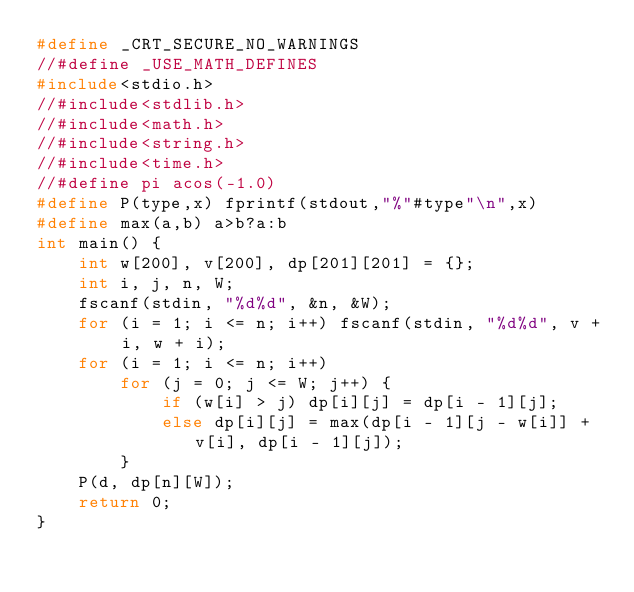<code> <loc_0><loc_0><loc_500><loc_500><_C_>#define _CRT_SECURE_NO_WARNINGS
//#define _USE_MATH_DEFINES
#include<stdio.h>
//#include<stdlib.h>
//#include<math.h>
//#include<string.h>
//#include<time.h>
//#define pi acos(-1.0)
#define P(type,x) fprintf(stdout,"%"#type"\n",x)
#define max(a,b) a>b?a:b
int main() {
	int w[200], v[200], dp[201][201] = {};
	int i, j, n, W;
	fscanf(stdin, "%d%d", &n, &W);
	for (i = 1; i <= n; i++) fscanf(stdin, "%d%d", v + i, w + i);
	for (i = 1; i <= n; i++)
		for (j = 0; j <= W; j++) {
			if (w[i] > j) dp[i][j] = dp[i - 1][j];
			else dp[i][j] = max(dp[i - 1][j - w[i]] + v[i], dp[i - 1][j]);
		}
	P(d, dp[n][W]);
	return 0;
}</code> 